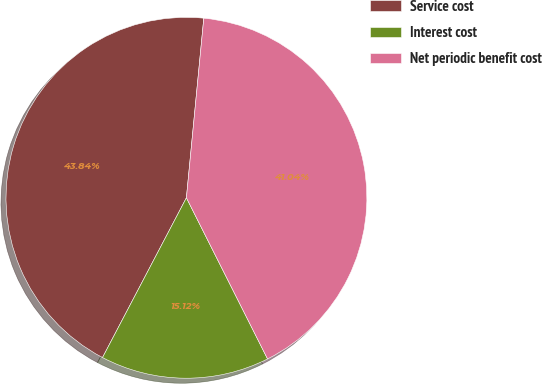Convert chart. <chart><loc_0><loc_0><loc_500><loc_500><pie_chart><fcel>Service cost<fcel>Interest cost<fcel>Net periodic benefit cost<nl><fcel>43.84%<fcel>15.12%<fcel>41.04%<nl></chart> 